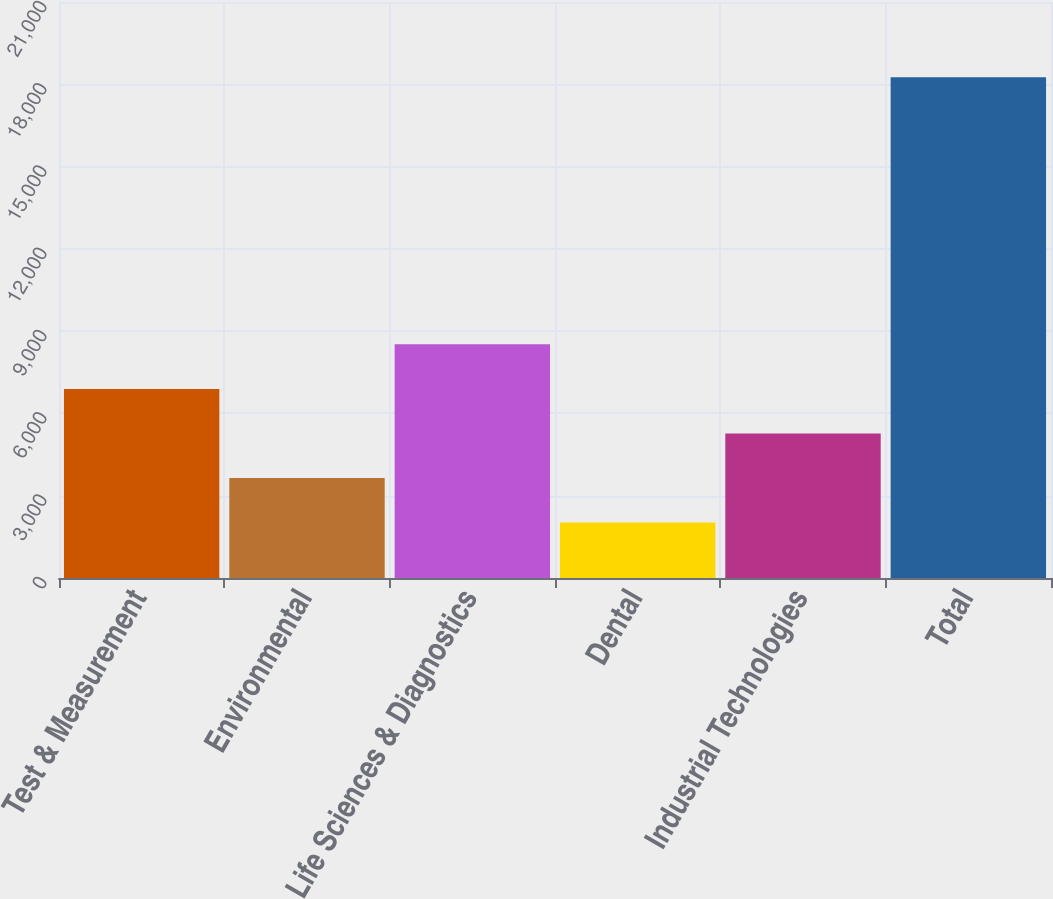Convert chart to OTSL. <chart><loc_0><loc_0><loc_500><loc_500><bar_chart><fcel>Test & Measurement<fcel>Environmental<fcel>Life Sciences & Diagnostics<fcel>Dental<fcel>Industrial Technologies<fcel>Total<nl><fcel>6894.15<fcel>3646.65<fcel>8517.9<fcel>2022.9<fcel>5270.4<fcel>18260.4<nl></chart> 